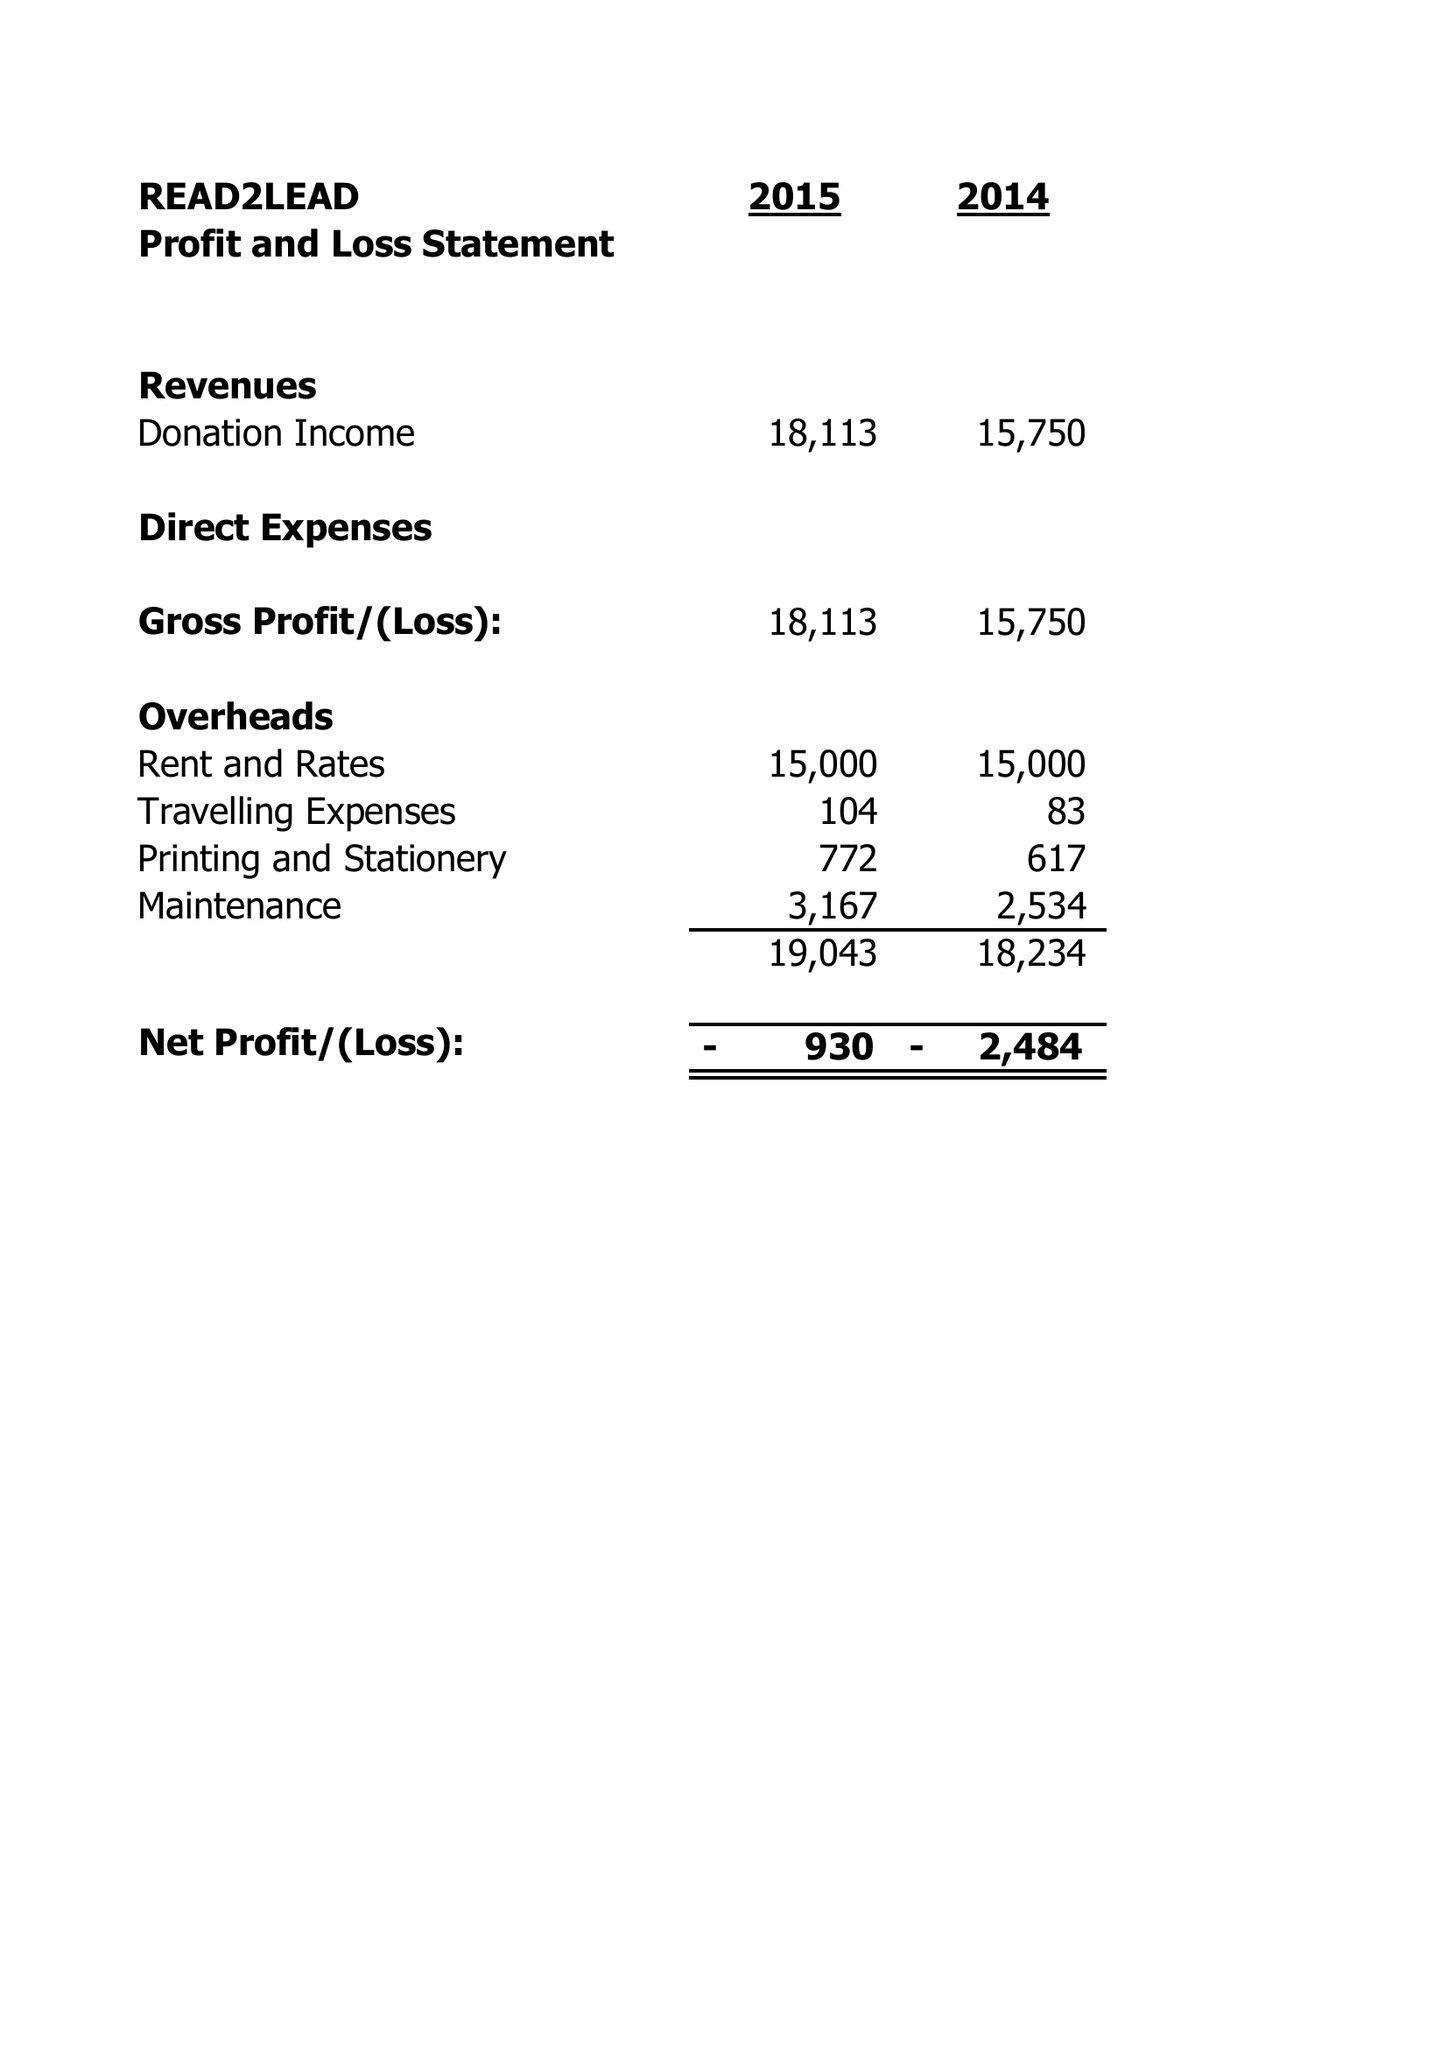What is the value for the charity_number?
Answer the question using a single word or phrase. 1151490 